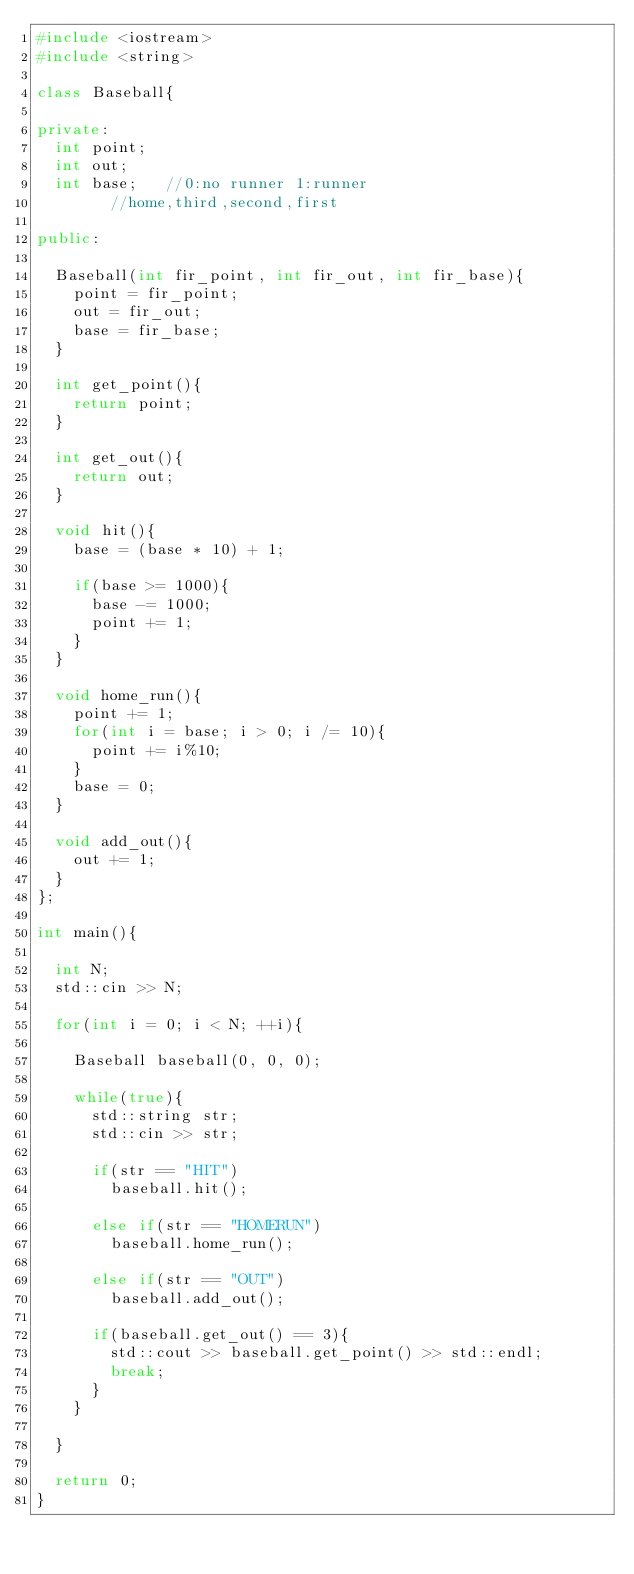<code> <loc_0><loc_0><loc_500><loc_500><_C++_>#include <iostream>
#include <string>

class Baseball{

private:
	int point;
	int out;
	int base;   //0:no runner 1:runner
				//home,third,second,first

public:

	Baseball(int fir_point, int fir_out, int fir_base){
		point = fir_point;
		out = fir_out;
		base = fir_base;
	}

	int get_point(){
		return point;
	}

	int get_out(){
		return out;
	}

	void hit(){
		base = (base * 10) + 1;
		
		if(base >= 1000){
			base -= 1000;
			point += 1;
		}
	}

	void home_run(){
		point += 1;
		for(int i = base; i > 0; i /= 10){
			point += i%10;
		}
		base = 0;
	}

	void add_out(){
		out += 1;
	}
};	

int main(){

	int N;
	std::cin >> N;

	for(int i = 0; i < N; ++i){

		Baseball baseball(0, 0, 0);

		while(true){
			std::string str;
			std::cin >> str;

			if(str == "HIT")
				baseball.hit();
			
			else if(str == "HOMERUN")
				baseball.home_run();

			else if(str == "OUT")
				baseball.add_out();
			
			if(baseball.get_out() == 3){
				std::cout >> baseball.get_point() >> std::endl;
				break;
			}
		}

	}

	return 0;
}


	</code> 